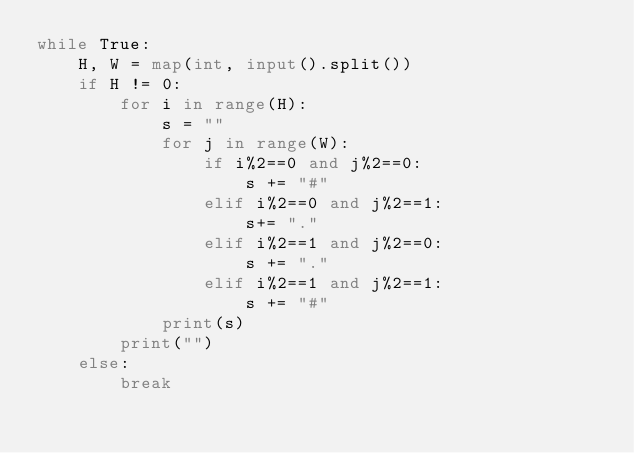<code> <loc_0><loc_0><loc_500><loc_500><_Python_>while True:
    H, W = map(int, input().split())
    if H != 0:
        for i in range(H):
            s = ""
            for j in range(W):
                if i%2==0 and j%2==0:
                    s += "#"
                elif i%2==0 and j%2==1:
                    s+= "."
                elif i%2==1 and j%2==0:
                    s += "."
                elif i%2==1 and j%2==1:
                    s += "#"
            print(s)
        print("")
    else:
        break

</code> 